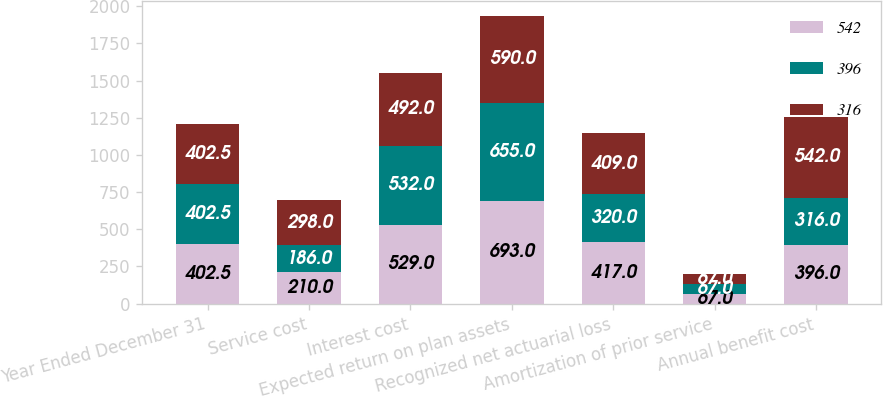<chart> <loc_0><loc_0><loc_500><loc_500><stacked_bar_chart><ecel><fcel>Year Ended December 31<fcel>Service cost<fcel>Interest cost<fcel>Expected return on plan assets<fcel>Recognized net actuarial loss<fcel>Amortization of prior service<fcel>Annual benefit cost<nl><fcel>542<fcel>402.5<fcel>210<fcel>529<fcel>693<fcel>417<fcel>67<fcel>396<nl><fcel>396<fcel>402.5<fcel>186<fcel>532<fcel>655<fcel>320<fcel>67<fcel>316<nl><fcel>316<fcel>402.5<fcel>298<fcel>492<fcel>590<fcel>409<fcel>67<fcel>542<nl></chart> 